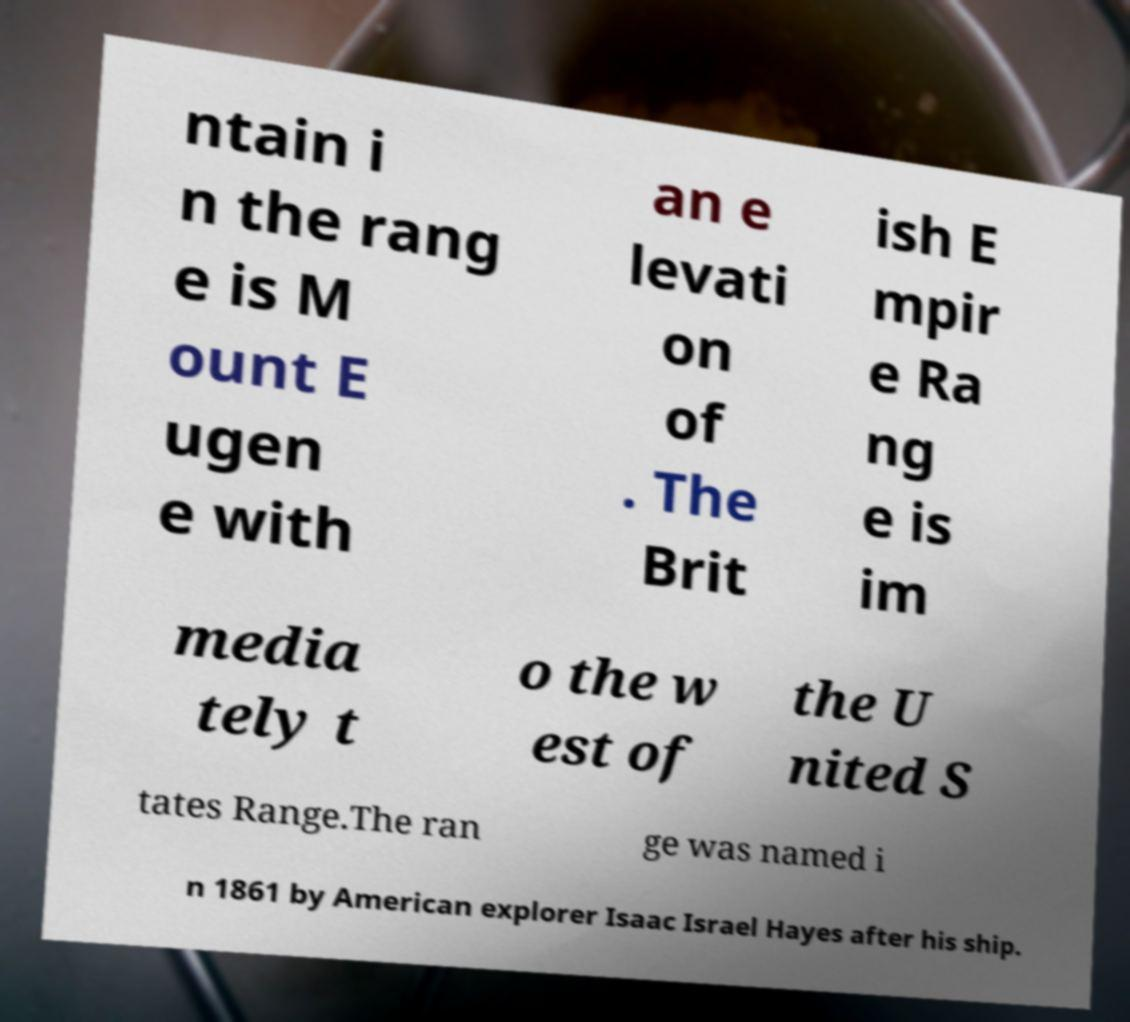Can you read and provide the text displayed in the image?This photo seems to have some interesting text. Can you extract and type it out for me? ntain i n the rang e is M ount E ugen e with an e levati on of . The Brit ish E mpir e Ra ng e is im media tely t o the w est of the U nited S tates Range.The ran ge was named i n 1861 by American explorer Isaac Israel Hayes after his ship. 